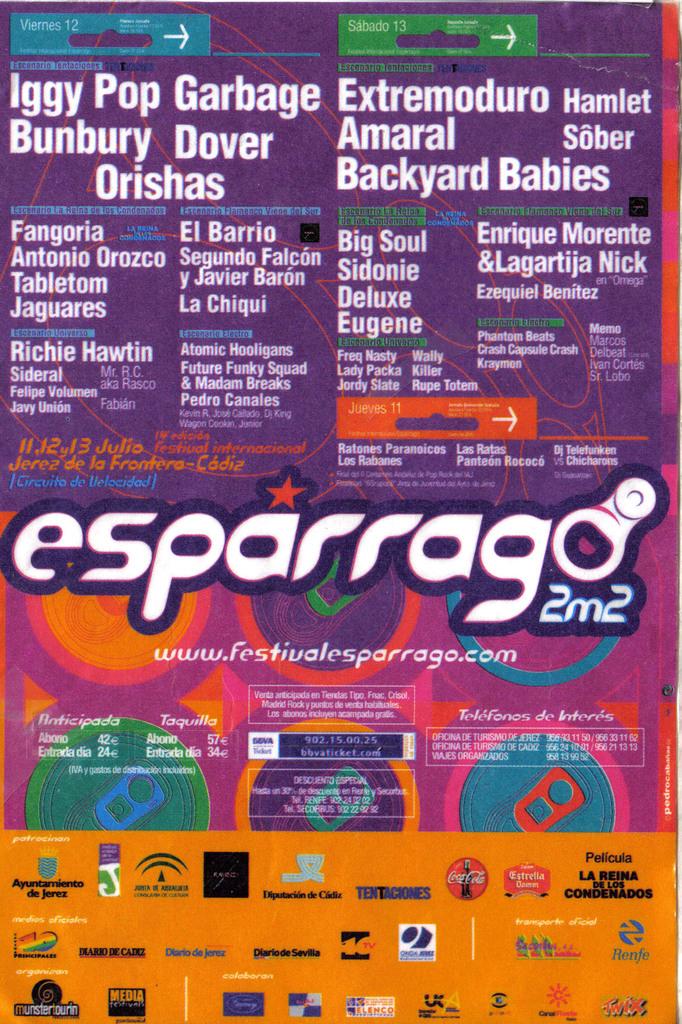Who is the first artist mentioned at the top left of the poster?
Keep it short and to the point. Iggy pop. 